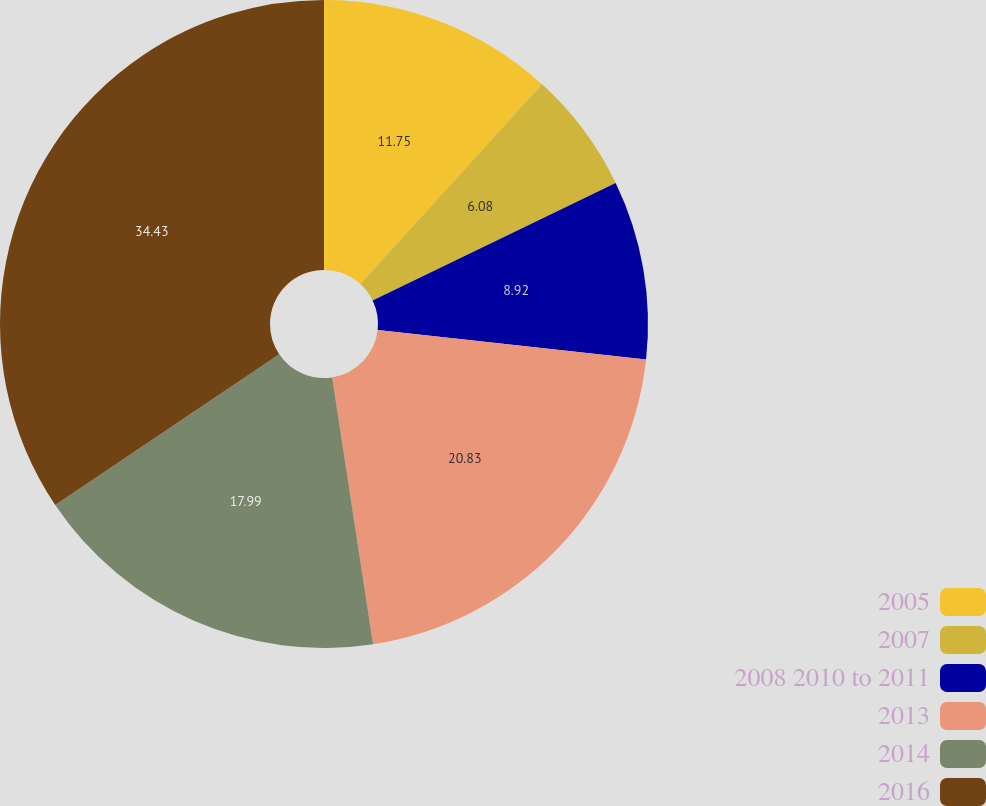Convert chart to OTSL. <chart><loc_0><loc_0><loc_500><loc_500><pie_chart><fcel>2005<fcel>2007<fcel>2008 2010 to 2011<fcel>2013<fcel>2014<fcel>2016<nl><fcel>11.75%<fcel>6.08%<fcel>8.92%<fcel>20.83%<fcel>17.99%<fcel>34.43%<nl></chart> 